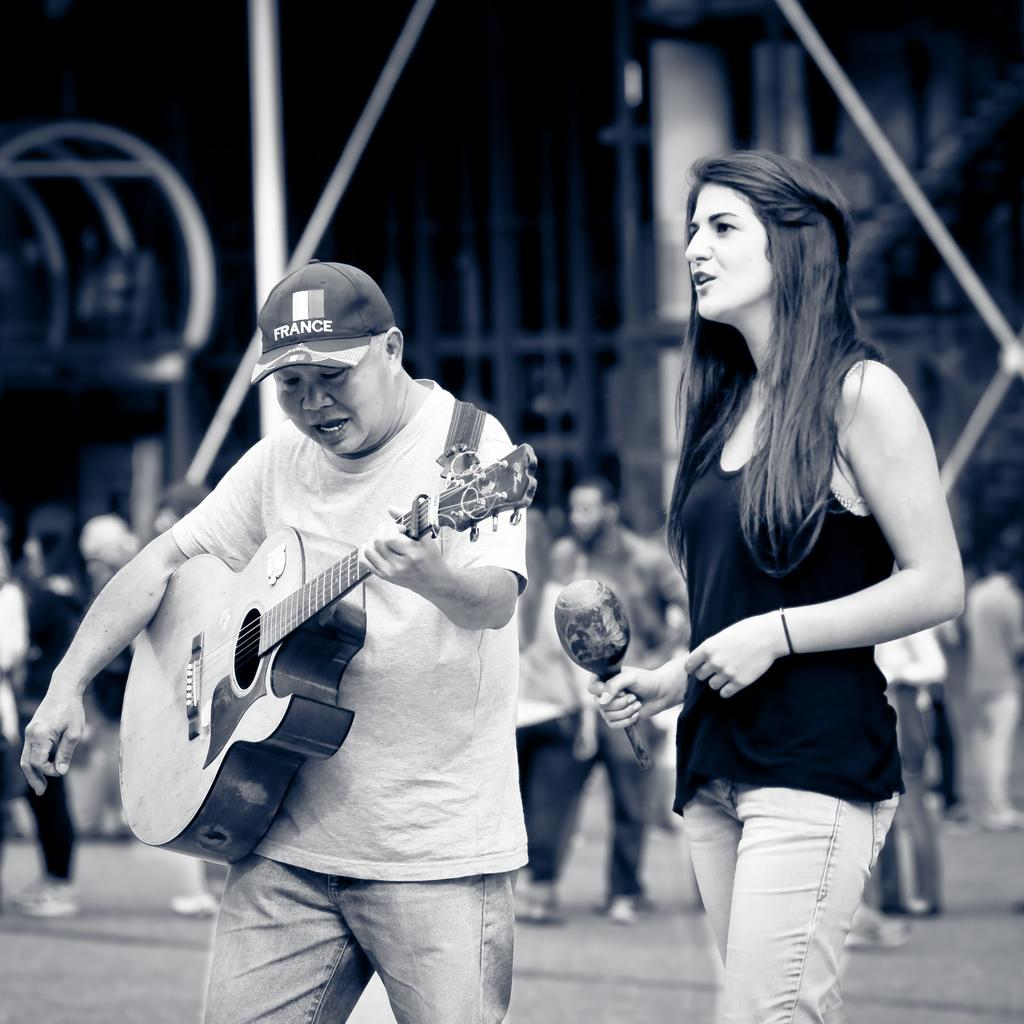How many people are present in the image? There are two people in the image. What are the two people holding? One person is holding a guitar, and the other person is holding a microphone. Can you describe the background of the image? There is a group of people in the background of the image. What type of smoke can be seen coming from the appliance in the image? There is no appliance or smoke present in the image. What discovery was made by the person holding the microphone in the image? There is no indication of a discovery being made in the image. 